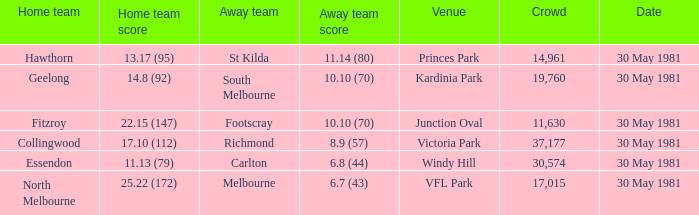Could you parse the entire table as a dict? {'header': ['Home team', 'Home team score', 'Away team', 'Away team score', 'Venue', 'Crowd', 'Date'], 'rows': [['Hawthorn', '13.17 (95)', 'St Kilda', '11.14 (80)', 'Princes Park', '14,961', '30 May 1981'], ['Geelong', '14.8 (92)', 'South Melbourne', '10.10 (70)', 'Kardinia Park', '19,760', '30 May 1981'], ['Fitzroy', '22.15 (147)', 'Footscray', '10.10 (70)', 'Junction Oval', '11,630', '30 May 1981'], ['Collingwood', '17.10 (112)', 'Richmond', '8.9 (57)', 'Victoria Park', '37,177', '30 May 1981'], ['Essendon', '11.13 (79)', 'Carlton', '6.8 (44)', 'Windy Hill', '30,574', '30 May 1981'], ['North Melbourne', '25.22 (172)', 'Melbourne', '6.7 (43)', 'VFL Park', '17,015', '30 May 1981']]} What did carlton achieve while being away? 6.8 (44). 